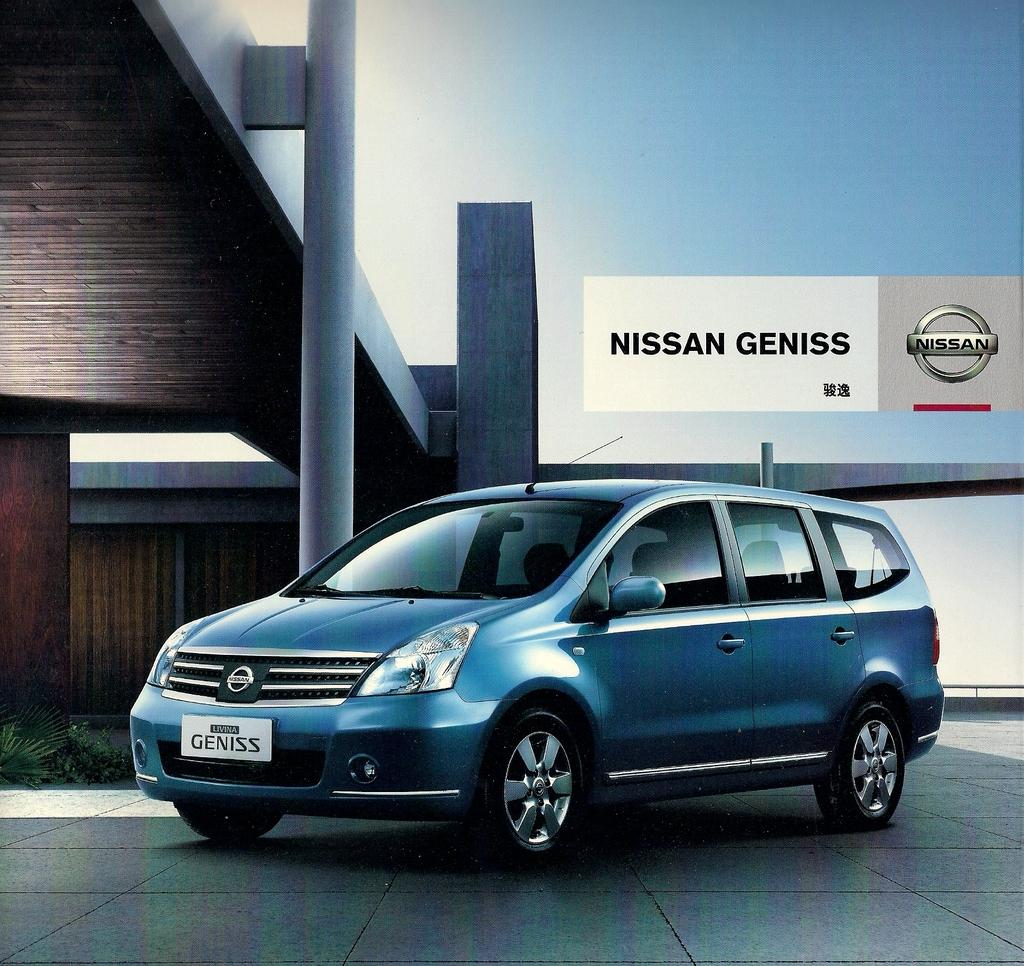<image>
Create a compact narrative representing the image presented. A SUV is parked next to a building beneath a sign saying Nissan Geniss 